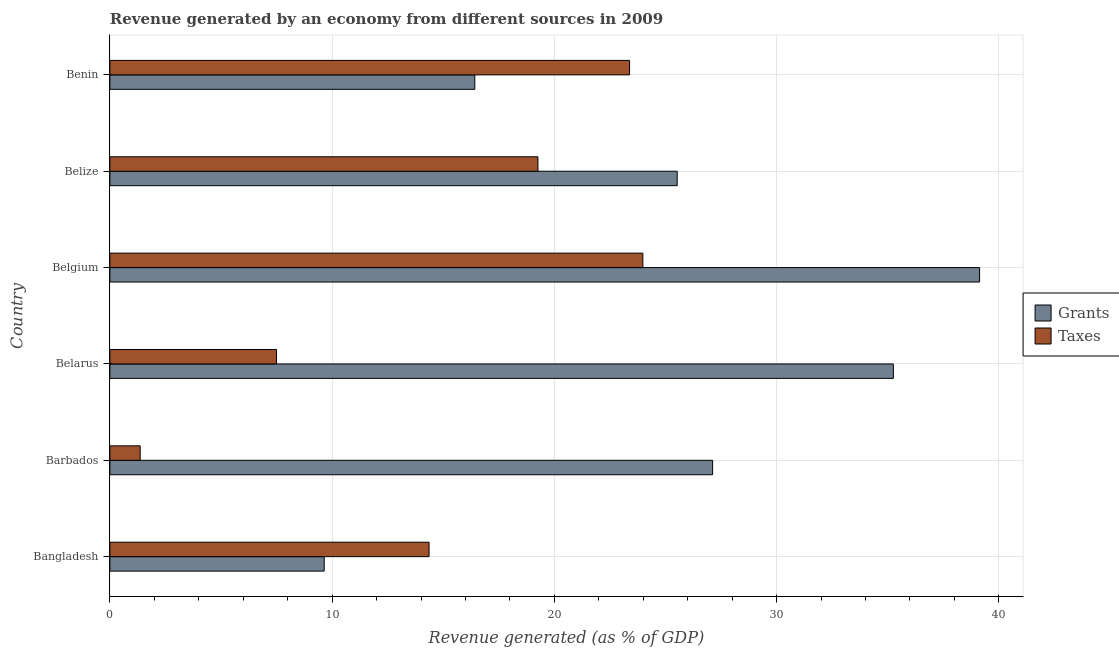How many different coloured bars are there?
Offer a terse response. 2. Are the number of bars on each tick of the Y-axis equal?
Make the answer very short. Yes. How many bars are there on the 3rd tick from the bottom?
Offer a terse response. 2. In how many cases, is the number of bars for a given country not equal to the number of legend labels?
Provide a succinct answer. 0. What is the revenue generated by grants in Barbados?
Give a very brief answer. 27.12. Across all countries, what is the maximum revenue generated by taxes?
Ensure brevity in your answer.  23.98. Across all countries, what is the minimum revenue generated by grants?
Provide a succinct answer. 9.64. In which country was the revenue generated by taxes minimum?
Ensure brevity in your answer.  Barbados. What is the total revenue generated by grants in the graph?
Offer a terse response. 153.09. What is the difference between the revenue generated by grants in Belgium and that in Belize?
Ensure brevity in your answer.  13.61. What is the difference between the revenue generated by grants in Belgium and the revenue generated by taxes in Belarus?
Offer a terse response. 31.63. What is the average revenue generated by grants per country?
Provide a short and direct response. 25.52. What is the difference between the revenue generated by grants and revenue generated by taxes in Benin?
Keep it short and to the point. -6.96. In how many countries, is the revenue generated by grants greater than 32 %?
Provide a succinct answer. 2. What is the ratio of the revenue generated by taxes in Belize to that in Benin?
Ensure brevity in your answer.  0.82. Is the difference between the revenue generated by grants in Bangladesh and Benin greater than the difference between the revenue generated by taxes in Bangladesh and Benin?
Your response must be concise. Yes. What is the difference between the highest and the second highest revenue generated by taxes?
Keep it short and to the point. 0.6. What is the difference between the highest and the lowest revenue generated by grants?
Your answer should be compact. 29.49. Is the sum of the revenue generated by taxes in Belgium and Belize greater than the maximum revenue generated by grants across all countries?
Your answer should be compact. Yes. What does the 2nd bar from the top in Belarus represents?
Make the answer very short. Grants. What does the 1st bar from the bottom in Barbados represents?
Provide a short and direct response. Grants. How many bars are there?
Your answer should be very brief. 12. Are all the bars in the graph horizontal?
Offer a very short reply. Yes. How many countries are there in the graph?
Your answer should be very brief. 6. Are the values on the major ticks of X-axis written in scientific E-notation?
Provide a short and direct response. No. What is the title of the graph?
Keep it short and to the point. Revenue generated by an economy from different sources in 2009. What is the label or title of the X-axis?
Give a very brief answer. Revenue generated (as % of GDP). What is the label or title of the Y-axis?
Give a very brief answer. Country. What is the Revenue generated (as % of GDP) of Grants in Bangladesh?
Provide a succinct answer. 9.64. What is the Revenue generated (as % of GDP) in Taxes in Bangladesh?
Give a very brief answer. 14.36. What is the Revenue generated (as % of GDP) in Grants in Barbados?
Provide a succinct answer. 27.12. What is the Revenue generated (as % of GDP) in Taxes in Barbados?
Your response must be concise. 1.36. What is the Revenue generated (as % of GDP) in Grants in Belarus?
Ensure brevity in your answer.  35.25. What is the Revenue generated (as % of GDP) in Taxes in Belarus?
Your response must be concise. 7.5. What is the Revenue generated (as % of GDP) of Grants in Belgium?
Provide a short and direct response. 39.13. What is the Revenue generated (as % of GDP) of Taxes in Belgium?
Your answer should be compact. 23.98. What is the Revenue generated (as % of GDP) of Grants in Belize?
Offer a terse response. 25.53. What is the Revenue generated (as % of GDP) of Taxes in Belize?
Your answer should be very brief. 19.26. What is the Revenue generated (as % of GDP) of Grants in Benin?
Your answer should be compact. 16.42. What is the Revenue generated (as % of GDP) of Taxes in Benin?
Provide a short and direct response. 23.38. Across all countries, what is the maximum Revenue generated (as % of GDP) in Grants?
Your answer should be very brief. 39.13. Across all countries, what is the maximum Revenue generated (as % of GDP) in Taxes?
Give a very brief answer. 23.98. Across all countries, what is the minimum Revenue generated (as % of GDP) in Grants?
Provide a succinct answer. 9.64. Across all countries, what is the minimum Revenue generated (as % of GDP) in Taxes?
Give a very brief answer. 1.36. What is the total Revenue generated (as % of GDP) of Grants in the graph?
Offer a very short reply. 153.09. What is the total Revenue generated (as % of GDP) in Taxes in the graph?
Provide a short and direct response. 89.85. What is the difference between the Revenue generated (as % of GDP) of Grants in Bangladesh and that in Barbados?
Give a very brief answer. -17.48. What is the difference between the Revenue generated (as % of GDP) in Taxes in Bangladesh and that in Barbados?
Provide a succinct answer. 13. What is the difference between the Revenue generated (as % of GDP) of Grants in Bangladesh and that in Belarus?
Provide a succinct answer. -25.61. What is the difference between the Revenue generated (as % of GDP) in Taxes in Bangladesh and that in Belarus?
Your answer should be compact. 6.86. What is the difference between the Revenue generated (as % of GDP) in Grants in Bangladesh and that in Belgium?
Keep it short and to the point. -29.49. What is the difference between the Revenue generated (as % of GDP) of Taxes in Bangladesh and that in Belgium?
Ensure brevity in your answer.  -9.62. What is the difference between the Revenue generated (as % of GDP) in Grants in Bangladesh and that in Belize?
Give a very brief answer. -15.88. What is the difference between the Revenue generated (as % of GDP) of Taxes in Bangladesh and that in Belize?
Offer a very short reply. -4.9. What is the difference between the Revenue generated (as % of GDP) in Grants in Bangladesh and that in Benin?
Offer a terse response. -6.78. What is the difference between the Revenue generated (as % of GDP) of Taxes in Bangladesh and that in Benin?
Offer a very short reply. -9.02. What is the difference between the Revenue generated (as % of GDP) of Grants in Barbados and that in Belarus?
Provide a short and direct response. -8.13. What is the difference between the Revenue generated (as % of GDP) in Taxes in Barbados and that in Belarus?
Your answer should be very brief. -6.13. What is the difference between the Revenue generated (as % of GDP) in Grants in Barbados and that in Belgium?
Give a very brief answer. -12.01. What is the difference between the Revenue generated (as % of GDP) in Taxes in Barbados and that in Belgium?
Ensure brevity in your answer.  -22.62. What is the difference between the Revenue generated (as % of GDP) of Grants in Barbados and that in Belize?
Give a very brief answer. 1.59. What is the difference between the Revenue generated (as % of GDP) of Taxes in Barbados and that in Belize?
Provide a succinct answer. -17.9. What is the difference between the Revenue generated (as % of GDP) in Grants in Barbados and that in Benin?
Your answer should be very brief. 10.7. What is the difference between the Revenue generated (as % of GDP) of Taxes in Barbados and that in Benin?
Your response must be concise. -22.02. What is the difference between the Revenue generated (as % of GDP) of Grants in Belarus and that in Belgium?
Your answer should be very brief. -3.88. What is the difference between the Revenue generated (as % of GDP) in Taxes in Belarus and that in Belgium?
Keep it short and to the point. -16.48. What is the difference between the Revenue generated (as % of GDP) in Grants in Belarus and that in Belize?
Offer a very short reply. 9.73. What is the difference between the Revenue generated (as % of GDP) of Taxes in Belarus and that in Belize?
Offer a very short reply. -11.76. What is the difference between the Revenue generated (as % of GDP) in Grants in Belarus and that in Benin?
Your answer should be very brief. 18.83. What is the difference between the Revenue generated (as % of GDP) in Taxes in Belarus and that in Benin?
Provide a short and direct response. -15.89. What is the difference between the Revenue generated (as % of GDP) of Grants in Belgium and that in Belize?
Your answer should be very brief. 13.61. What is the difference between the Revenue generated (as % of GDP) of Taxes in Belgium and that in Belize?
Offer a very short reply. 4.72. What is the difference between the Revenue generated (as % of GDP) of Grants in Belgium and that in Benin?
Keep it short and to the point. 22.71. What is the difference between the Revenue generated (as % of GDP) in Taxes in Belgium and that in Benin?
Make the answer very short. 0.6. What is the difference between the Revenue generated (as % of GDP) in Grants in Belize and that in Benin?
Your answer should be compact. 9.11. What is the difference between the Revenue generated (as % of GDP) in Taxes in Belize and that in Benin?
Give a very brief answer. -4.12. What is the difference between the Revenue generated (as % of GDP) of Grants in Bangladesh and the Revenue generated (as % of GDP) of Taxes in Barbados?
Your answer should be compact. 8.28. What is the difference between the Revenue generated (as % of GDP) in Grants in Bangladesh and the Revenue generated (as % of GDP) in Taxes in Belarus?
Your answer should be very brief. 2.15. What is the difference between the Revenue generated (as % of GDP) of Grants in Bangladesh and the Revenue generated (as % of GDP) of Taxes in Belgium?
Offer a very short reply. -14.34. What is the difference between the Revenue generated (as % of GDP) in Grants in Bangladesh and the Revenue generated (as % of GDP) in Taxes in Belize?
Make the answer very short. -9.62. What is the difference between the Revenue generated (as % of GDP) of Grants in Bangladesh and the Revenue generated (as % of GDP) of Taxes in Benin?
Ensure brevity in your answer.  -13.74. What is the difference between the Revenue generated (as % of GDP) in Grants in Barbados and the Revenue generated (as % of GDP) in Taxes in Belarus?
Ensure brevity in your answer.  19.62. What is the difference between the Revenue generated (as % of GDP) of Grants in Barbados and the Revenue generated (as % of GDP) of Taxes in Belgium?
Give a very brief answer. 3.14. What is the difference between the Revenue generated (as % of GDP) of Grants in Barbados and the Revenue generated (as % of GDP) of Taxes in Belize?
Your response must be concise. 7.86. What is the difference between the Revenue generated (as % of GDP) of Grants in Barbados and the Revenue generated (as % of GDP) of Taxes in Benin?
Give a very brief answer. 3.74. What is the difference between the Revenue generated (as % of GDP) in Grants in Belarus and the Revenue generated (as % of GDP) in Taxes in Belgium?
Your answer should be compact. 11.27. What is the difference between the Revenue generated (as % of GDP) in Grants in Belarus and the Revenue generated (as % of GDP) in Taxes in Belize?
Give a very brief answer. 15.99. What is the difference between the Revenue generated (as % of GDP) in Grants in Belarus and the Revenue generated (as % of GDP) in Taxes in Benin?
Offer a very short reply. 11.87. What is the difference between the Revenue generated (as % of GDP) of Grants in Belgium and the Revenue generated (as % of GDP) of Taxes in Belize?
Your response must be concise. 19.87. What is the difference between the Revenue generated (as % of GDP) of Grants in Belgium and the Revenue generated (as % of GDP) of Taxes in Benin?
Your response must be concise. 15.75. What is the difference between the Revenue generated (as % of GDP) in Grants in Belize and the Revenue generated (as % of GDP) in Taxes in Benin?
Provide a succinct answer. 2.14. What is the average Revenue generated (as % of GDP) in Grants per country?
Offer a very short reply. 25.52. What is the average Revenue generated (as % of GDP) of Taxes per country?
Provide a succinct answer. 14.97. What is the difference between the Revenue generated (as % of GDP) in Grants and Revenue generated (as % of GDP) in Taxes in Bangladesh?
Keep it short and to the point. -4.72. What is the difference between the Revenue generated (as % of GDP) in Grants and Revenue generated (as % of GDP) in Taxes in Barbados?
Your response must be concise. 25.76. What is the difference between the Revenue generated (as % of GDP) in Grants and Revenue generated (as % of GDP) in Taxes in Belarus?
Your response must be concise. 27.75. What is the difference between the Revenue generated (as % of GDP) of Grants and Revenue generated (as % of GDP) of Taxes in Belgium?
Keep it short and to the point. 15.15. What is the difference between the Revenue generated (as % of GDP) of Grants and Revenue generated (as % of GDP) of Taxes in Belize?
Make the answer very short. 6.27. What is the difference between the Revenue generated (as % of GDP) in Grants and Revenue generated (as % of GDP) in Taxes in Benin?
Make the answer very short. -6.96. What is the ratio of the Revenue generated (as % of GDP) in Grants in Bangladesh to that in Barbados?
Your answer should be very brief. 0.36. What is the ratio of the Revenue generated (as % of GDP) of Taxes in Bangladesh to that in Barbados?
Your answer should be compact. 10.54. What is the ratio of the Revenue generated (as % of GDP) in Grants in Bangladesh to that in Belarus?
Your response must be concise. 0.27. What is the ratio of the Revenue generated (as % of GDP) in Taxes in Bangladesh to that in Belarus?
Ensure brevity in your answer.  1.92. What is the ratio of the Revenue generated (as % of GDP) in Grants in Bangladesh to that in Belgium?
Keep it short and to the point. 0.25. What is the ratio of the Revenue generated (as % of GDP) in Taxes in Bangladesh to that in Belgium?
Ensure brevity in your answer.  0.6. What is the ratio of the Revenue generated (as % of GDP) of Grants in Bangladesh to that in Belize?
Provide a short and direct response. 0.38. What is the ratio of the Revenue generated (as % of GDP) of Taxes in Bangladesh to that in Belize?
Your answer should be very brief. 0.75. What is the ratio of the Revenue generated (as % of GDP) of Grants in Bangladesh to that in Benin?
Give a very brief answer. 0.59. What is the ratio of the Revenue generated (as % of GDP) in Taxes in Bangladesh to that in Benin?
Your response must be concise. 0.61. What is the ratio of the Revenue generated (as % of GDP) in Grants in Barbados to that in Belarus?
Your answer should be compact. 0.77. What is the ratio of the Revenue generated (as % of GDP) in Taxes in Barbados to that in Belarus?
Keep it short and to the point. 0.18. What is the ratio of the Revenue generated (as % of GDP) of Grants in Barbados to that in Belgium?
Keep it short and to the point. 0.69. What is the ratio of the Revenue generated (as % of GDP) in Taxes in Barbados to that in Belgium?
Keep it short and to the point. 0.06. What is the ratio of the Revenue generated (as % of GDP) of Taxes in Barbados to that in Belize?
Give a very brief answer. 0.07. What is the ratio of the Revenue generated (as % of GDP) in Grants in Barbados to that in Benin?
Provide a short and direct response. 1.65. What is the ratio of the Revenue generated (as % of GDP) of Taxes in Barbados to that in Benin?
Make the answer very short. 0.06. What is the ratio of the Revenue generated (as % of GDP) of Grants in Belarus to that in Belgium?
Provide a short and direct response. 0.9. What is the ratio of the Revenue generated (as % of GDP) of Taxes in Belarus to that in Belgium?
Provide a short and direct response. 0.31. What is the ratio of the Revenue generated (as % of GDP) of Grants in Belarus to that in Belize?
Offer a terse response. 1.38. What is the ratio of the Revenue generated (as % of GDP) in Taxes in Belarus to that in Belize?
Provide a short and direct response. 0.39. What is the ratio of the Revenue generated (as % of GDP) of Grants in Belarus to that in Benin?
Provide a short and direct response. 2.15. What is the ratio of the Revenue generated (as % of GDP) in Taxes in Belarus to that in Benin?
Your response must be concise. 0.32. What is the ratio of the Revenue generated (as % of GDP) in Grants in Belgium to that in Belize?
Provide a short and direct response. 1.53. What is the ratio of the Revenue generated (as % of GDP) of Taxes in Belgium to that in Belize?
Offer a terse response. 1.25. What is the ratio of the Revenue generated (as % of GDP) of Grants in Belgium to that in Benin?
Make the answer very short. 2.38. What is the ratio of the Revenue generated (as % of GDP) in Taxes in Belgium to that in Benin?
Offer a very short reply. 1.03. What is the ratio of the Revenue generated (as % of GDP) of Grants in Belize to that in Benin?
Keep it short and to the point. 1.55. What is the ratio of the Revenue generated (as % of GDP) in Taxes in Belize to that in Benin?
Offer a very short reply. 0.82. What is the difference between the highest and the second highest Revenue generated (as % of GDP) in Grants?
Offer a terse response. 3.88. What is the difference between the highest and the second highest Revenue generated (as % of GDP) in Taxes?
Provide a succinct answer. 0.6. What is the difference between the highest and the lowest Revenue generated (as % of GDP) of Grants?
Your response must be concise. 29.49. What is the difference between the highest and the lowest Revenue generated (as % of GDP) of Taxes?
Ensure brevity in your answer.  22.62. 